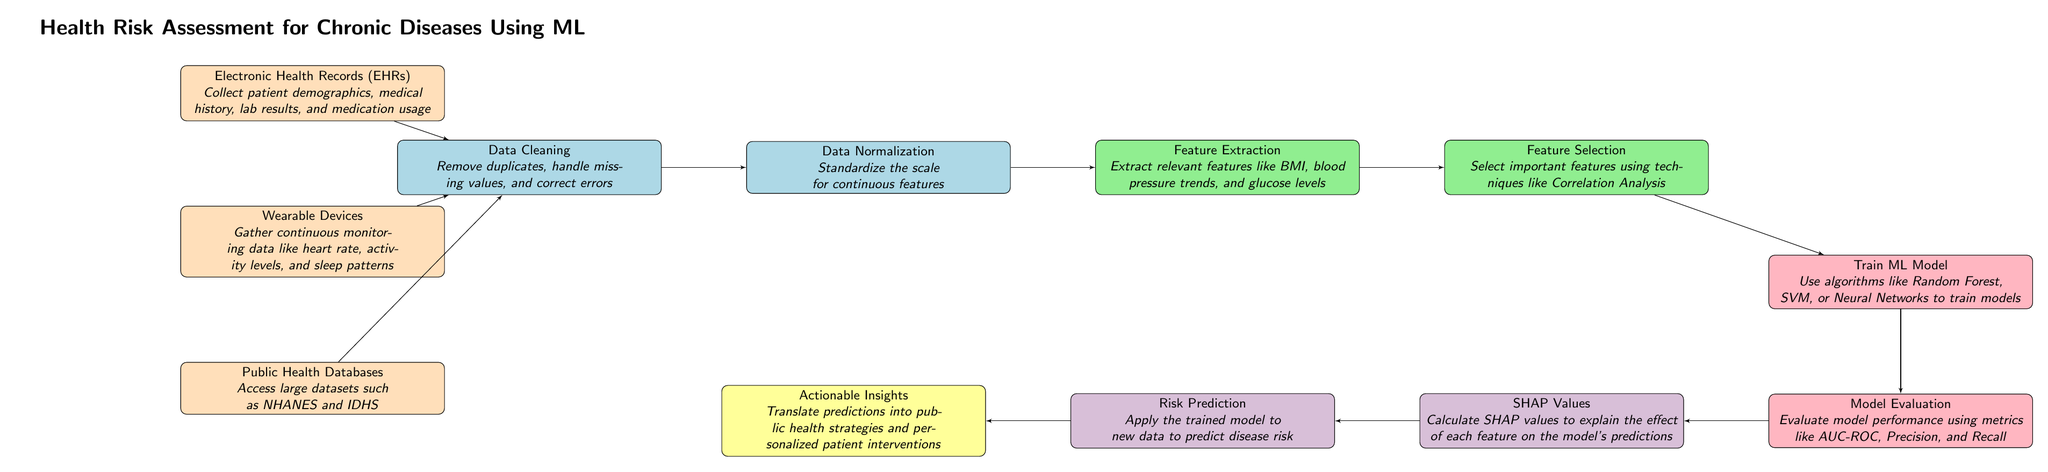What are the data sources mentioned in the diagram? The diagram lists three data sources: Electronic Health Records, Wearable Devices, and Public Health Databases. Each of these sources plays a role in collecting health-related data.
Answer: Electronic Health Records, Wearable Devices, Public Health Databases How many blocks are in the diagram? By counting each distinct block representing different stages, there are a total of eight blocks in the diagram that illustrate the process of health risk assessment.
Answer: Eight What is the first step in the process according to the diagram? The first block is labeled "Electronic Health Records" and represents the initial step where patient data is collected before any preprocessing is done.
Answer: Electronic Health Records Which step follows "Data Normalization"? The diagram shows that after "Data Normalization," the next step is "Feature Extraction," indicating that normalization is foundational for feature extraction.
Answer: Feature Extraction What type of algorithms can be used to train the model? The diagram mentions "Random Forest, SVM, or Neural Networks" as examples of algorithms that can be utilized to train the machine learning model, providing options for the modeling process.
Answer: Random Forest, SVM, or Neural Networks How does SHAP values contribute to the process? The diagram indicates that SHAP values are calculated to "explain the effect of each feature on the model's predictions," highlighting their importance in model interpretability and understanding prediction outcomes.
Answer: Explain the effect of each feature What is the outcome of applying the trained model to new data? According to the diagram, the purpose of applying the trained model to new data is to make "Risk Prediction" which helps estimate the likelihood of chronic diseases in individuals.
Answer: Risk Prediction Which block is directly connected to "Model Evaluation"? The block that comes directly after "Model Evaluation" is "SHAP Values," indicating that model evaluation is followed by an interpretability step that explains predictions.
Answer: SHAP Values What is the final outcome represented in the diagram? The final block labeled "Actionable Insights" represents the outcome where the results of predictions are translated into practical strategies and interventions within public health.
Answer: Actionable Insights 